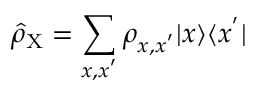<formula> <loc_0><loc_0><loc_500><loc_500>\hat { \rho } _ { X } = \sum _ { x , x ^ { ^ { \prime } } } \rho _ { x , x ^ { ^ { \prime } } } | x \rangle \langle x ^ { ^ { \prime } } |</formula> 